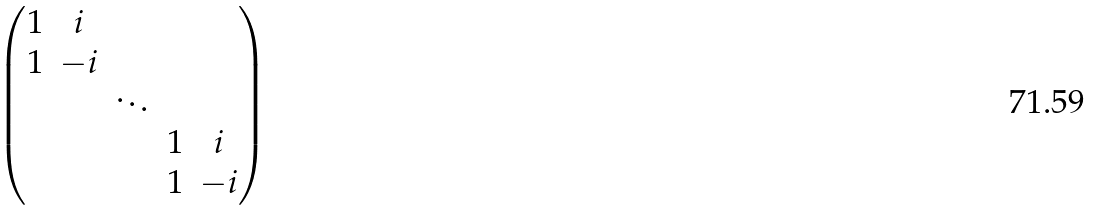Convert formula to latex. <formula><loc_0><loc_0><loc_500><loc_500>\begin{pmatrix} 1 & i & & & \\ 1 & - i & & & \\ & & \ddots & & \\ & & & 1 & i \\ & & & 1 & - i \end{pmatrix}</formula> 